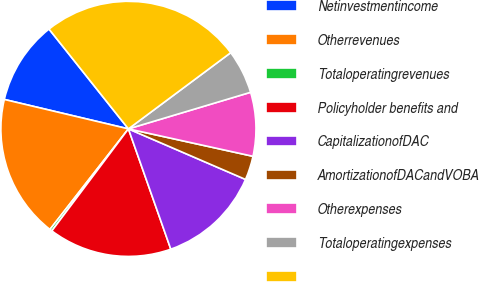Convert chart. <chart><loc_0><loc_0><loc_500><loc_500><pie_chart><fcel>Netinvestmentincome<fcel>Otherrevenues<fcel>Totaloperatingrevenues<fcel>Policyholder benefits and<fcel>CapitalizationofDAC<fcel>AmortizationofDACandVOBA<fcel>Otherexpenses<fcel>Totaloperatingexpenses<fcel>Unnamed: 8<nl><fcel>10.6%<fcel>18.16%<fcel>0.3%<fcel>15.64%<fcel>13.12%<fcel>3.04%<fcel>8.08%<fcel>5.56%<fcel>25.51%<nl></chart> 